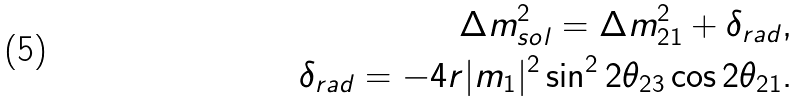Convert formula to latex. <formula><loc_0><loc_0><loc_500><loc_500>\Delta m ^ { 2 } _ { s o l } = \Delta m ^ { 2 } _ { 2 1 } + \delta _ { r a d } , \\ \delta _ { r a d } = - 4 r | m _ { 1 } | ^ { 2 } \sin ^ { 2 } 2 \theta _ { 2 3 } \cos 2 \theta _ { 2 1 } .</formula> 